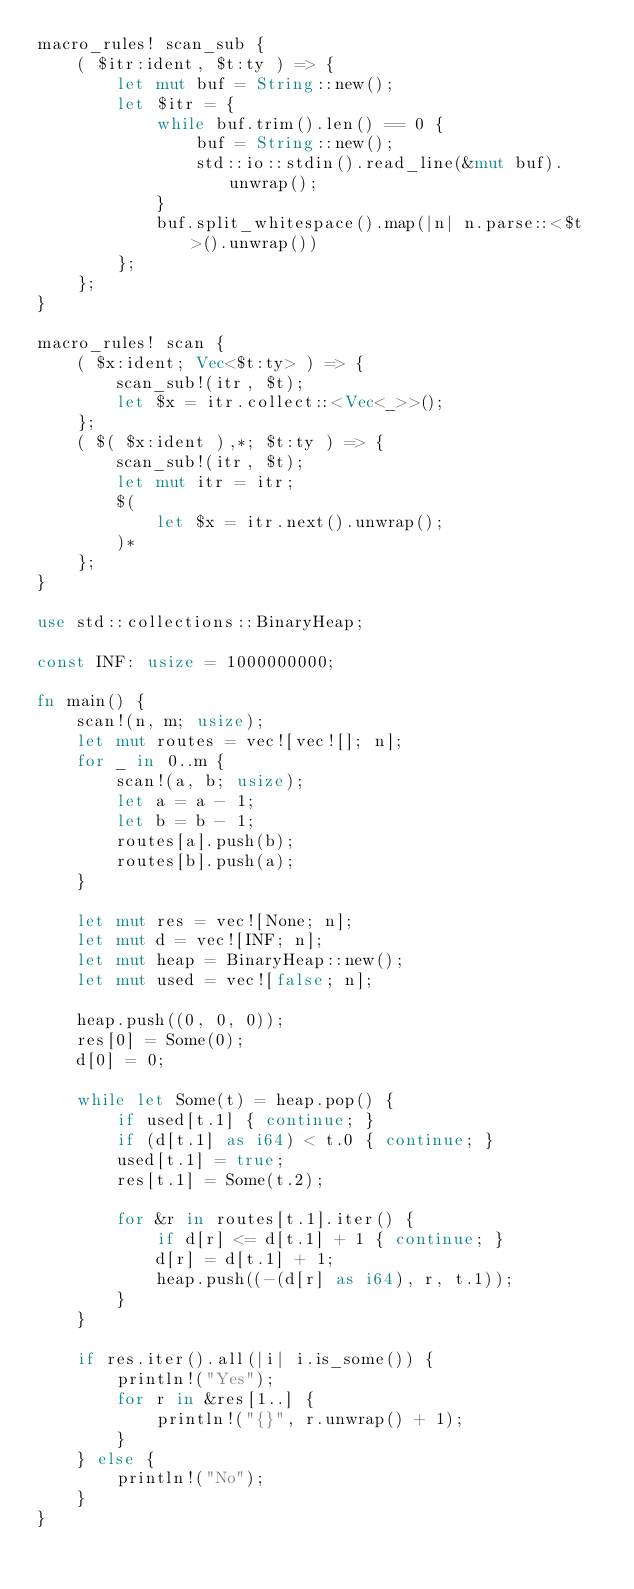Convert code to text. <code><loc_0><loc_0><loc_500><loc_500><_Rust_>macro_rules! scan_sub {
    ( $itr:ident, $t:ty ) => {
        let mut buf = String::new();
        let $itr = {
            while buf.trim().len() == 0 {
                buf = String::new();
                std::io::stdin().read_line(&mut buf).unwrap();
            }
            buf.split_whitespace().map(|n| n.parse::<$t>().unwrap())
        };
    };
}

macro_rules! scan {
    ( $x:ident; Vec<$t:ty> ) => {
        scan_sub!(itr, $t);
        let $x = itr.collect::<Vec<_>>();
    };
    ( $( $x:ident ),*; $t:ty ) => {
        scan_sub!(itr, $t);
        let mut itr = itr;
        $(
            let $x = itr.next().unwrap();
        )*
    };
}

use std::collections::BinaryHeap;

const INF: usize = 1000000000;

fn main() {
    scan!(n, m; usize);
    let mut routes = vec![vec![]; n];
    for _ in 0..m {
        scan!(a, b; usize);
        let a = a - 1;
        let b = b - 1;
        routes[a].push(b);
        routes[b].push(a);
    }

    let mut res = vec![None; n];
    let mut d = vec![INF; n];
    let mut heap = BinaryHeap::new();
    let mut used = vec![false; n];

    heap.push((0, 0, 0));
    res[0] = Some(0);
    d[0] = 0;

    while let Some(t) = heap.pop() {
        if used[t.1] { continue; }
        if (d[t.1] as i64) < t.0 { continue; }
        used[t.1] = true;
        res[t.1] = Some(t.2);

        for &r in routes[t.1].iter() {
            if d[r] <= d[t.1] + 1 { continue; }
            d[r] = d[t.1] + 1;
            heap.push((-(d[r] as i64), r, t.1));
        }
    }

    if res.iter().all(|i| i.is_some()) {
        println!("Yes");
        for r in &res[1..] {
            println!("{}", r.unwrap() + 1);
        }
    } else {
        println!("No");
    }
}
</code> 